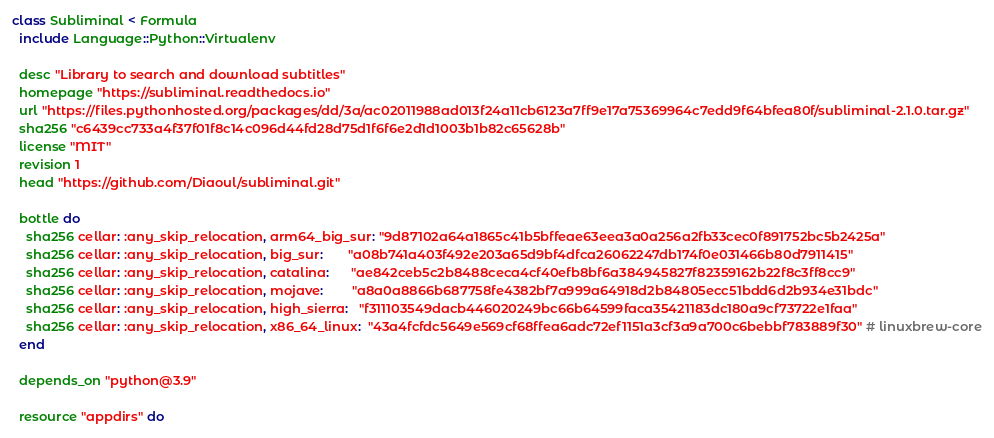<code> <loc_0><loc_0><loc_500><loc_500><_Ruby_>class Subliminal < Formula
  include Language::Python::Virtualenv

  desc "Library to search and download subtitles"
  homepage "https://subliminal.readthedocs.io"
  url "https://files.pythonhosted.org/packages/dd/3a/ac02011988ad013f24a11cb6123a7ff9e17a75369964c7edd9f64bfea80f/subliminal-2.1.0.tar.gz"
  sha256 "c6439cc733a4f37f01f8c14c096d44fd28d75d1f6f6e2d1d1003b1b82c65628b"
  license "MIT"
  revision 1
  head "https://github.com/Diaoul/subliminal.git"

  bottle do
    sha256 cellar: :any_skip_relocation, arm64_big_sur: "9d87102a64a1865c41b5bffeae63eea3a0a256a2fb33cec0f891752bc5b2425a"
    sha256 cellar: :any_skip_relocation, big_sur:       "a08b741a403f492e203a65d9bf4dfca26062247db174f0e031466b80d7911415"
    sha256 cellar: :any_skip_relocation, catalina:      "ae842ceb5c2b8488ceca4cf40efb8bf6a384945827f82359162b22f8c3ff8cc9"
    sha256 cellar: :any_skip_relocation, mojave:        "a8a0a8866b687758fe4382bf7a999a64918d2b84805ecc51bdd6d2b934e31bdc"
    sha256 cellar: :any_skip_relocation, high_sierra:   "f311103549dacb446020249bc66b64599faca35421183dc180a9cf73722e1faa"
    sha256 cellar: :any_skip_relocation, x86_64_linux:  "43a4fcfdc5649e569cf68ffea6adc72ef1151a3cf3a9a700c6bebbf783889f30" # linuxbrew-core
  end

  depends_on "python@3.9"

  resource "appdirs" do</code> 